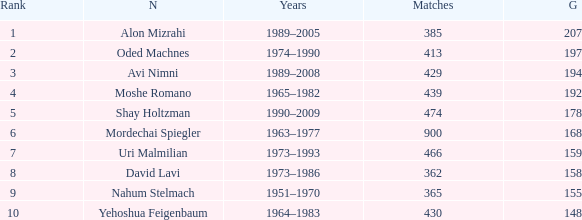What is the Rank of the player with 158 Goals in more than 362 Matches? 0.0. 